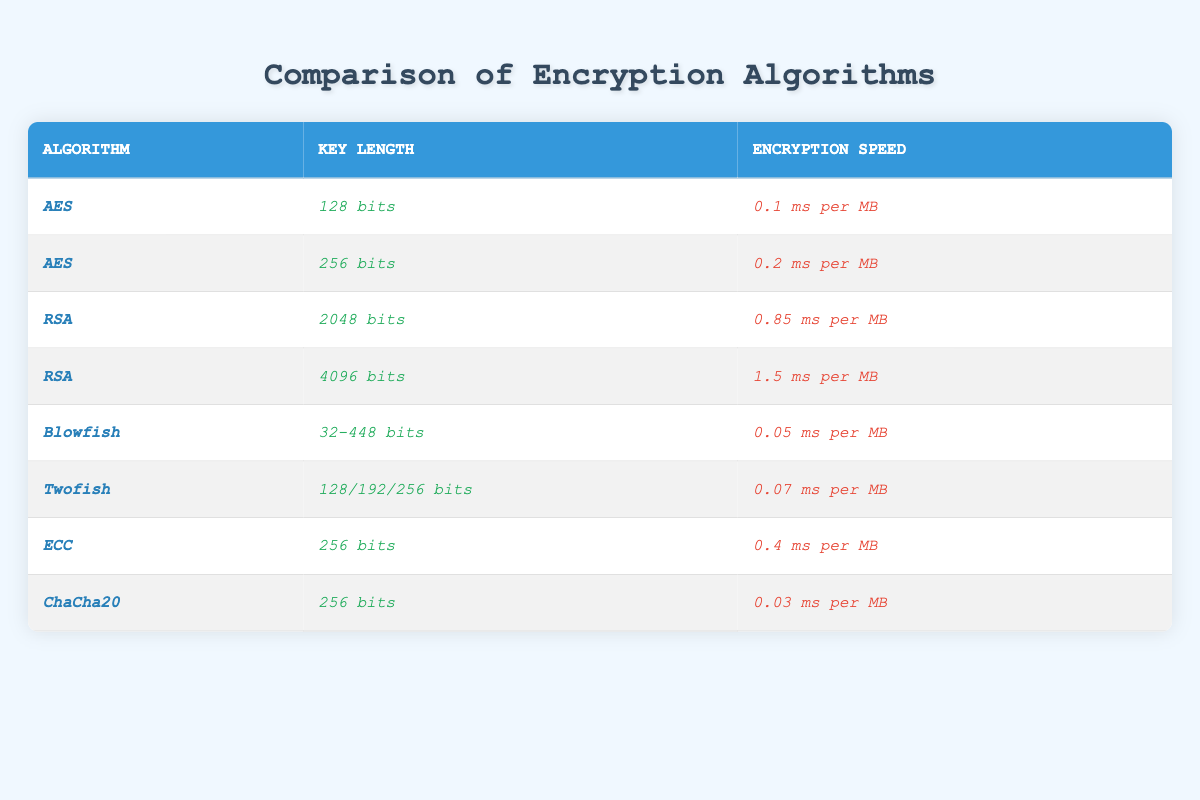What is the encryption speed of AES with a key length of 128 bits? The table shows that the encryption speed for _AES_ with a key length of _128 bits_ is _0.1 ms per MB_.
Answer: 0.1 ms per MB Which encryption algorithm has the longest key length, and what is that length? By examining the table, _RSA_ has the longest key length at _4096 bits_.
Answer: RSA, 4096 bits What is the encryption speed of Blowfish? The table indicates that the encryption speed of _Blowfish_ is _0.05 ms per MB_.
Answer: 0.05 ms per MB Is the encryption speed of ChaCha20 faster than that of ECC? Comparing the speeds from the table, _ChaCha20_ has a speed of _0.03 ms per MB_ and _ECC_ has a speed of _0.4 ms per MB_. Since _0.03 < 0.4_, ChaCha20 is faster.
Answer: Yes What is the average encryption speed of AES algorithms presented in this table? The table presents two AES speeds: _0.1 ms per MB_ and _0.2 ms per MB_. Adding them gives _0.1 + 0.2 = 0.3 ms per MB_. Dividing by 2 to find the average yields _0.15 ms per MB_.
Answer: 0.15 ms per MB Which encryption algorithm has the fastest encryption speed and what is that speed? Looking at the speeds, _ChaCha20_ has the fastest encryption speed of _0.03 ms per MB_, which is lower than any other listed speed.
Answer: ChaCha20, 0.03 ms per MB How many encryption algorithms use a 256-bit key? The table shows _AES_, _ECC_, and _ChaCha20_ using a _256 bits_ key. This totals 3 algorithms.
Answer: 3 What is the difference in encryption speed between RSA with 2048 bits and 4096 bits? The speeds are _0.85 ms per MB_ for _RSA_ with _2048 bits_ and _1.5 ms per MB_ for _4096 bits_. The difference is _1.5 - 0.85 = 0.65 ms per MB_.
Answer: 0.65 ms per MB If we combine the key lengths of Twofish and Blowfish, what is their key length range? Twofish has key lengths of _128/192/256 bits_, and Blowfish has _32-448 bits_. The combined range is from _32 bits_ to _448 bits_, as Blowfish’s range extends beyond Twofish’s maximum key length.
Answer: 32 to 448 bits Which algorithm has the highest key length of all the algorithms presented? The table reveals that _RSA_ with a key length of _4096 bits_ holds the highest key length of all algorithms listed.
Answer: RSA, 4096 bits What percentage of the algorithms in the table have an encryption speed of less than 0.1 ms per MB? There are 8 algorithms total. _Blowfish_ (_0.05 ms per MB_) and _ChaCha20_ (_0.03 ms per MB_) have speeds less than _0.1 ms per MB_, so that's 2 out of 8. The percentage is _(2/8)*100 = 25%_.
Answer: 25% 